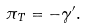<formula> <loc_0><loc_0><loc_500><loc_500>\pi _ { T } = - \gamma ^ { \prime } .</formula> 